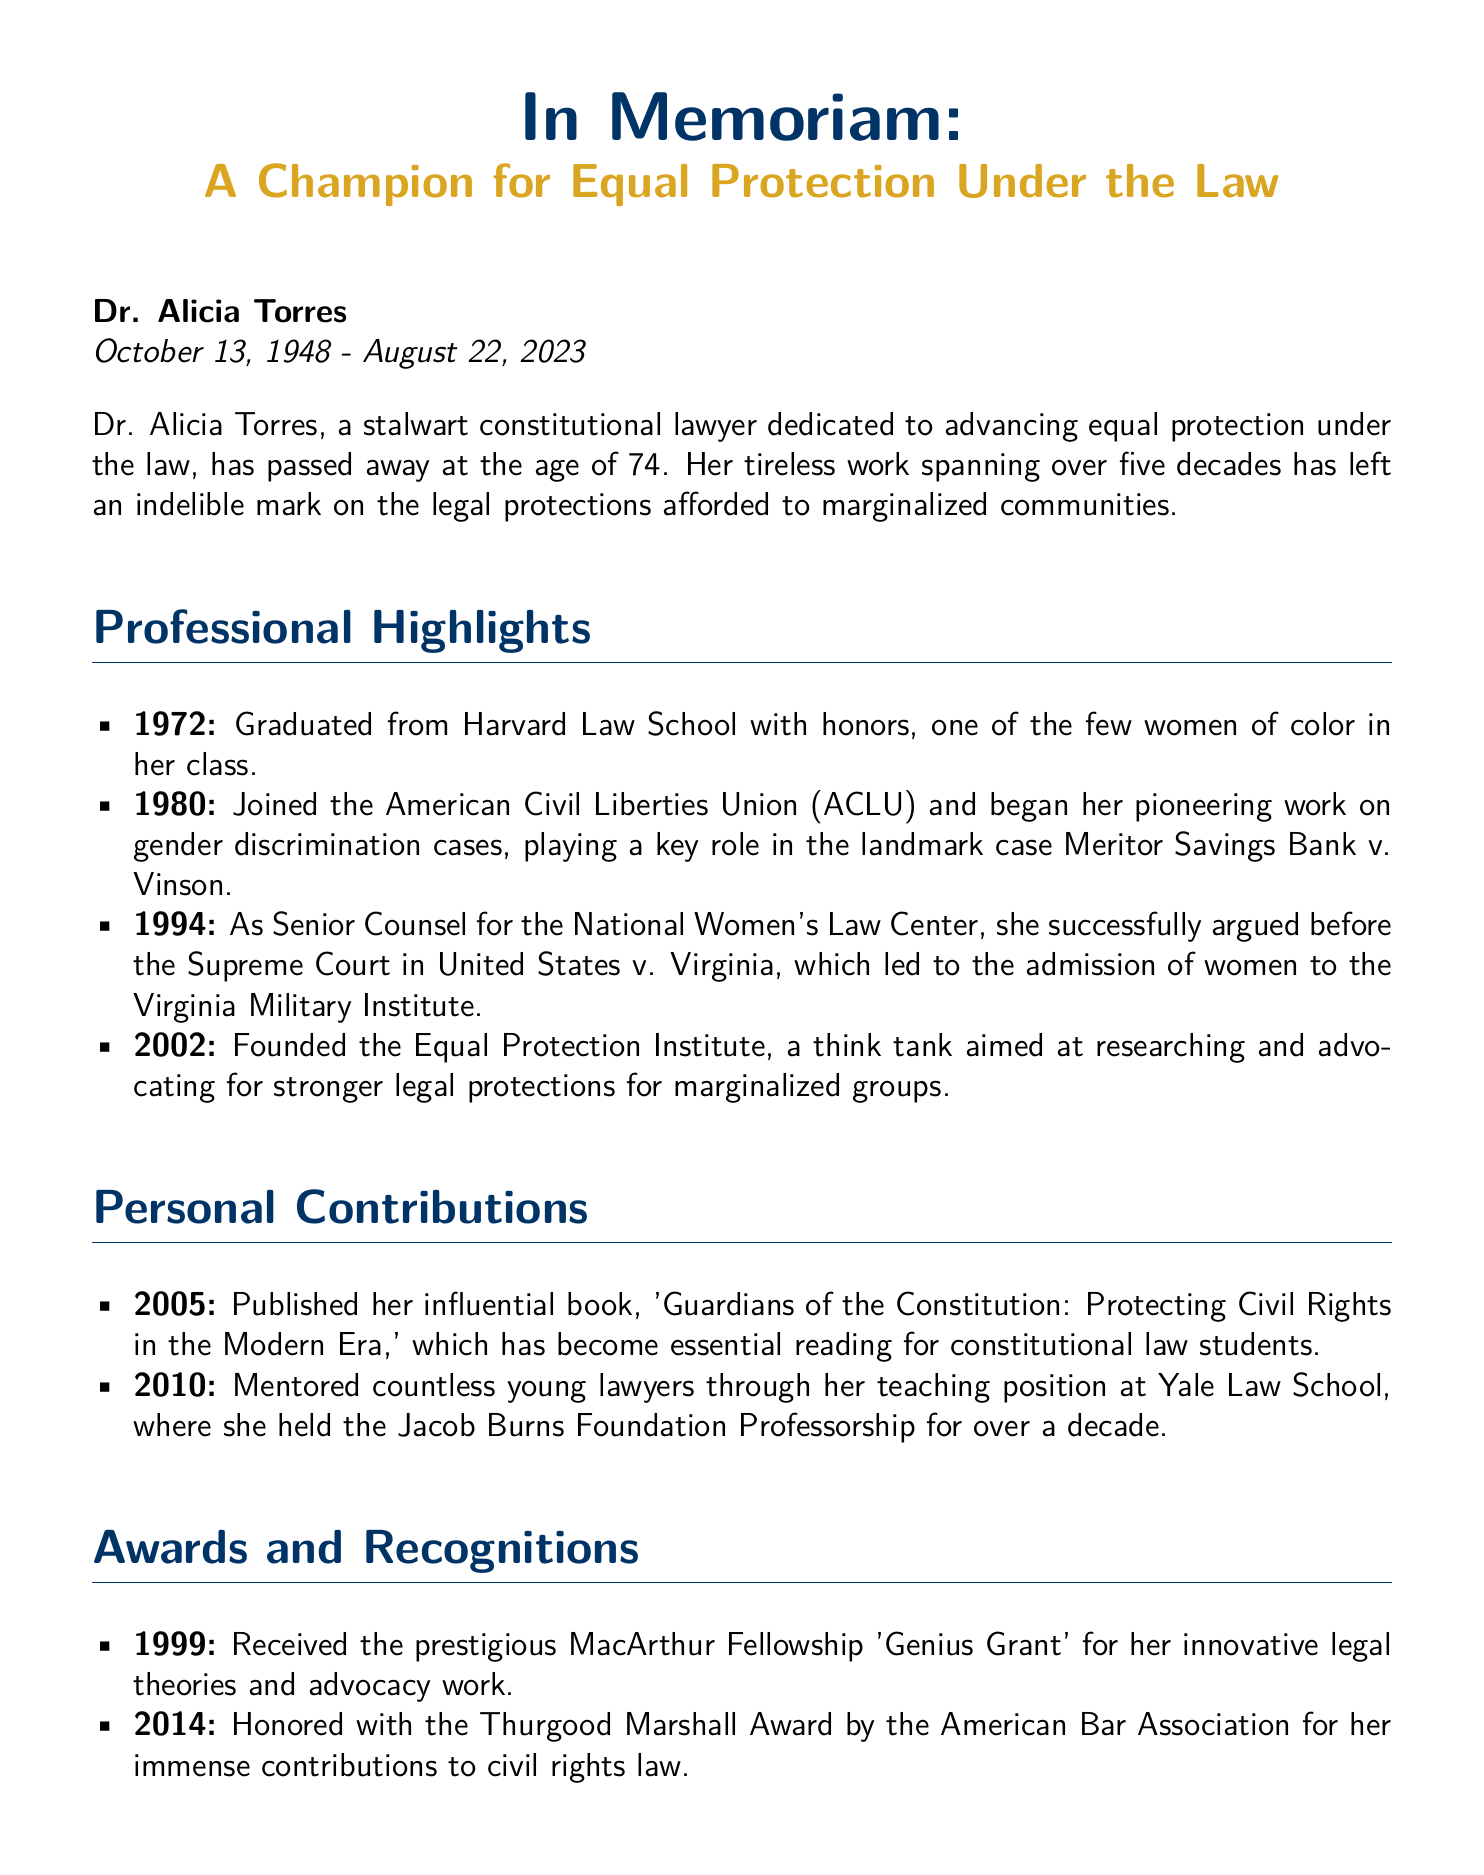What was the name of the individual honored in the obituary? The obituary honors Dr. Alicia Torres, a champion for equal protection under the law.
Answer: Dr. Alicia Torres What year did Dr. Torres graduate from Harvard Law School? The document states that Dr. Torres graduated in 1972.
Answer: 1972 Which organization did Dr. Torres join in 1980? Dr. Torres joined the American Civil Liberties Union (ACLU) in 1980.
Answer: American Civil Liberties Union (ACLU) What landmark case did Dr. Torres play a key role in? Dr. Torres played a key role in the landmark case Meritor Savings Bank v. Vinson.
Answer: Meritor Savings Bank v. Vinson How many children did Dr. Torres have? The document mentions that Dr. Torres is survived by two children.
Answer: two What award did Dr. Torres receive in 1999? Dr. Torres received the MacArthur Fellowship 'Genius Grant' in 1999.
Answer: MacArthur Fellowship 'Genius Grant' What was the title of Dr. Torres's influential book published in 2005? The title of her book is 'Guardians of the Constitution: Protecting Civil Rights in the Modern Era.'
Answer: Guardians of the Constitution: Protecting Civil Rights in the Modern Era In what year did Dr. Torres found the Equal Protection Institute? The Equal Protection Institute was founded by Dr. Torres in 2002.
Answer: 2002 What profession did Dr. Torres's son, Alex, pursue? Alex Torres is identified as a human rights lawyer in the document.
Answer: human rights lawyer 